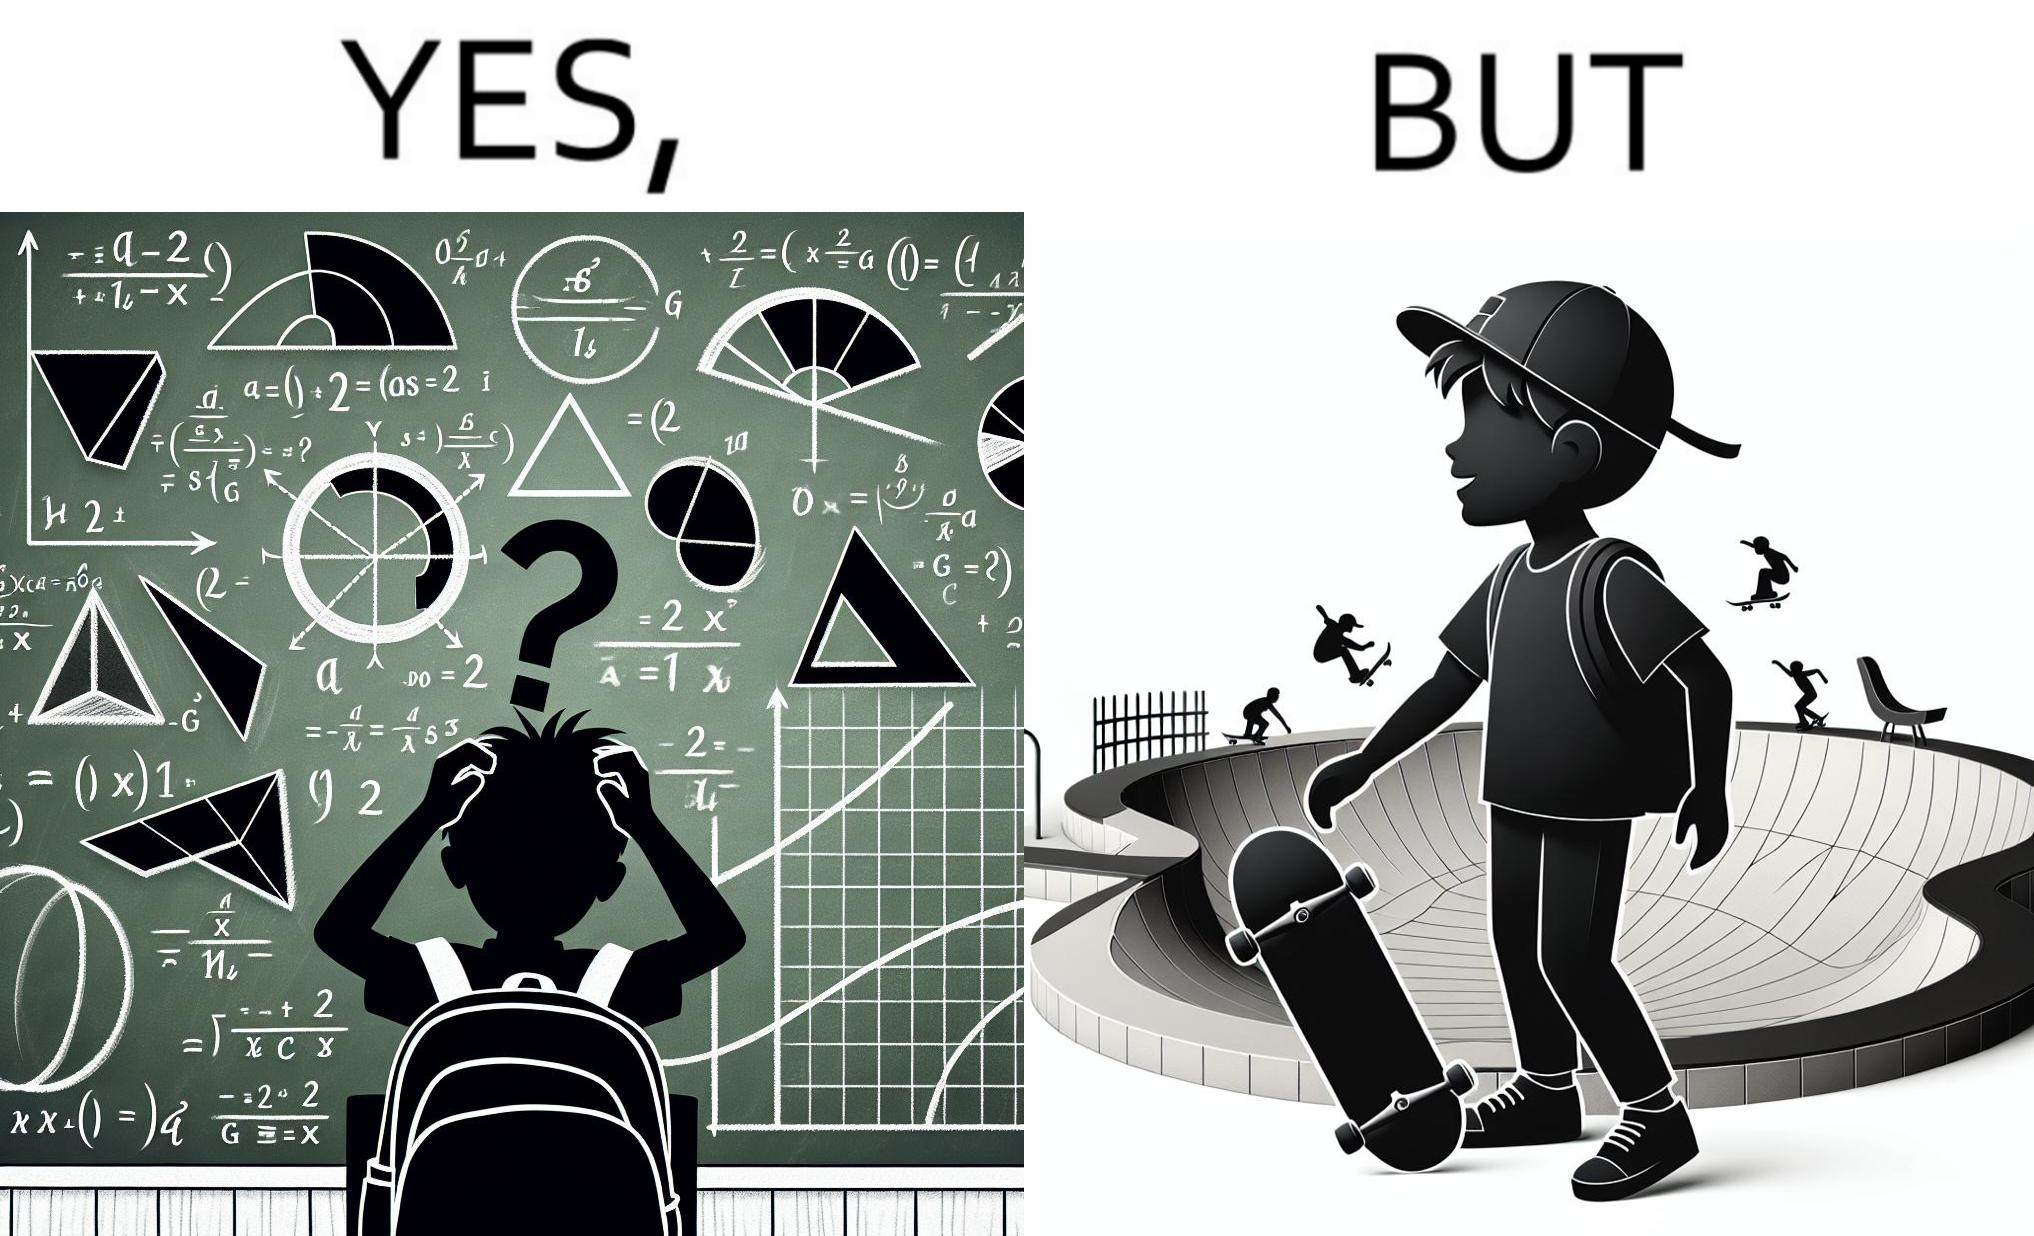What makes this image funny or satirical? The image is ironical beaucse while the boy does not enjoy studying mathematics and different geometric shapes like semi circle and trapezoid and graphs of trigonometric equations like that of a sine wave, he enjoys skateboarding on surfaces and bowls that are built based on the said geometric shapes and graphs of trigonometric equations. 